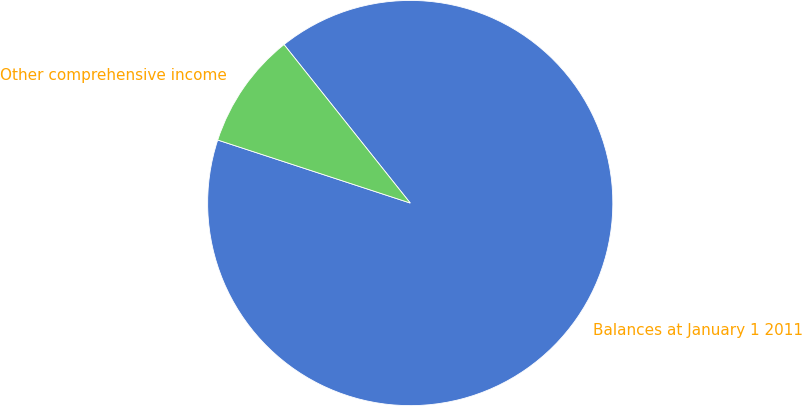<chart> <loc_0><loc_0><loc_500><loc_500><pie_chart><fcel>Balances at January 1 2011<fcel>Other comprehensive income<nl><fcel>90.74%<fcel>9.26%<nl></chart> 